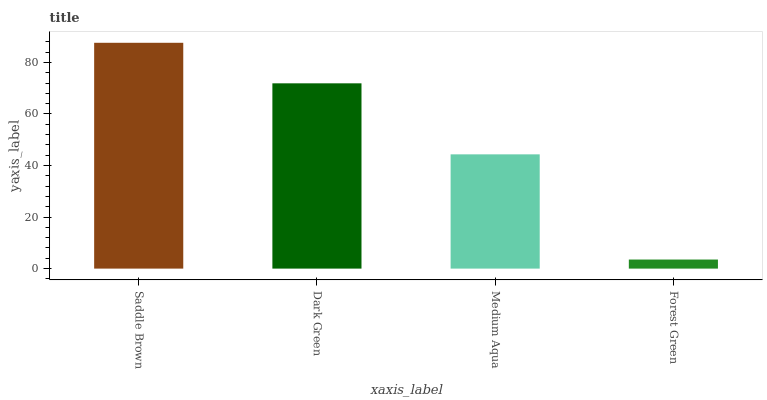Is Forest Green the minimum?
Answer yes or no. Yes. Is Saddle Brown the maximum?
Answer yes or no. Yes. Is Dark Green the minimum?
Answer yes or no. No. Is Dark Green the maximum?
Answer yes or no. No. Is Saddle Brown greater than Dark Green?
Answer yes or no. Yes. Is Dark Green less than Saddle Brown?
Answer yes or no. Yes. Is Dark Green greater than Saddle Brown?
Answer yes or no. No. Is Saddle Brown less than Dark Green?
Answer yes or no. No. Is Dark Green the high median?
Answer yes or no. Yes. Is Medium Aqua the low median?
Answer yes or no. Yes. Is Medium Aqua the high median?
Answer yes or no. No. Is Saddle Brown the low median?
Answer yes or no. No. 